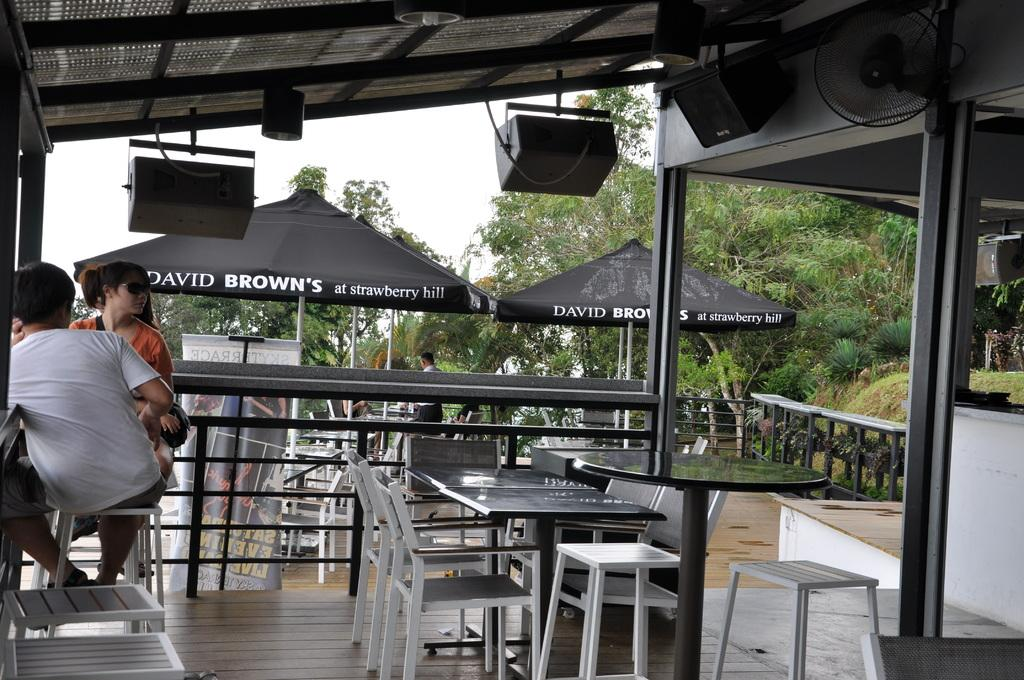How many people are sitting on chairs in the image? There are two people sitting on chairs on the left side of the image. What type of furniture is present in the image? There are tables and chairs in the image. What type of temporary shelters can be seen in the image? There are tents in the image. What type of natural vegetation is present in the image? There are trees in the image. What is visible in the background of the image? The sky is visible in the image. What type of plough is being used to support the arch in the image? There is no plough or arch present in the image. How does the support system for the arch work in the image? There is no arch present in the image, so it is not possible to discuss its support system. 